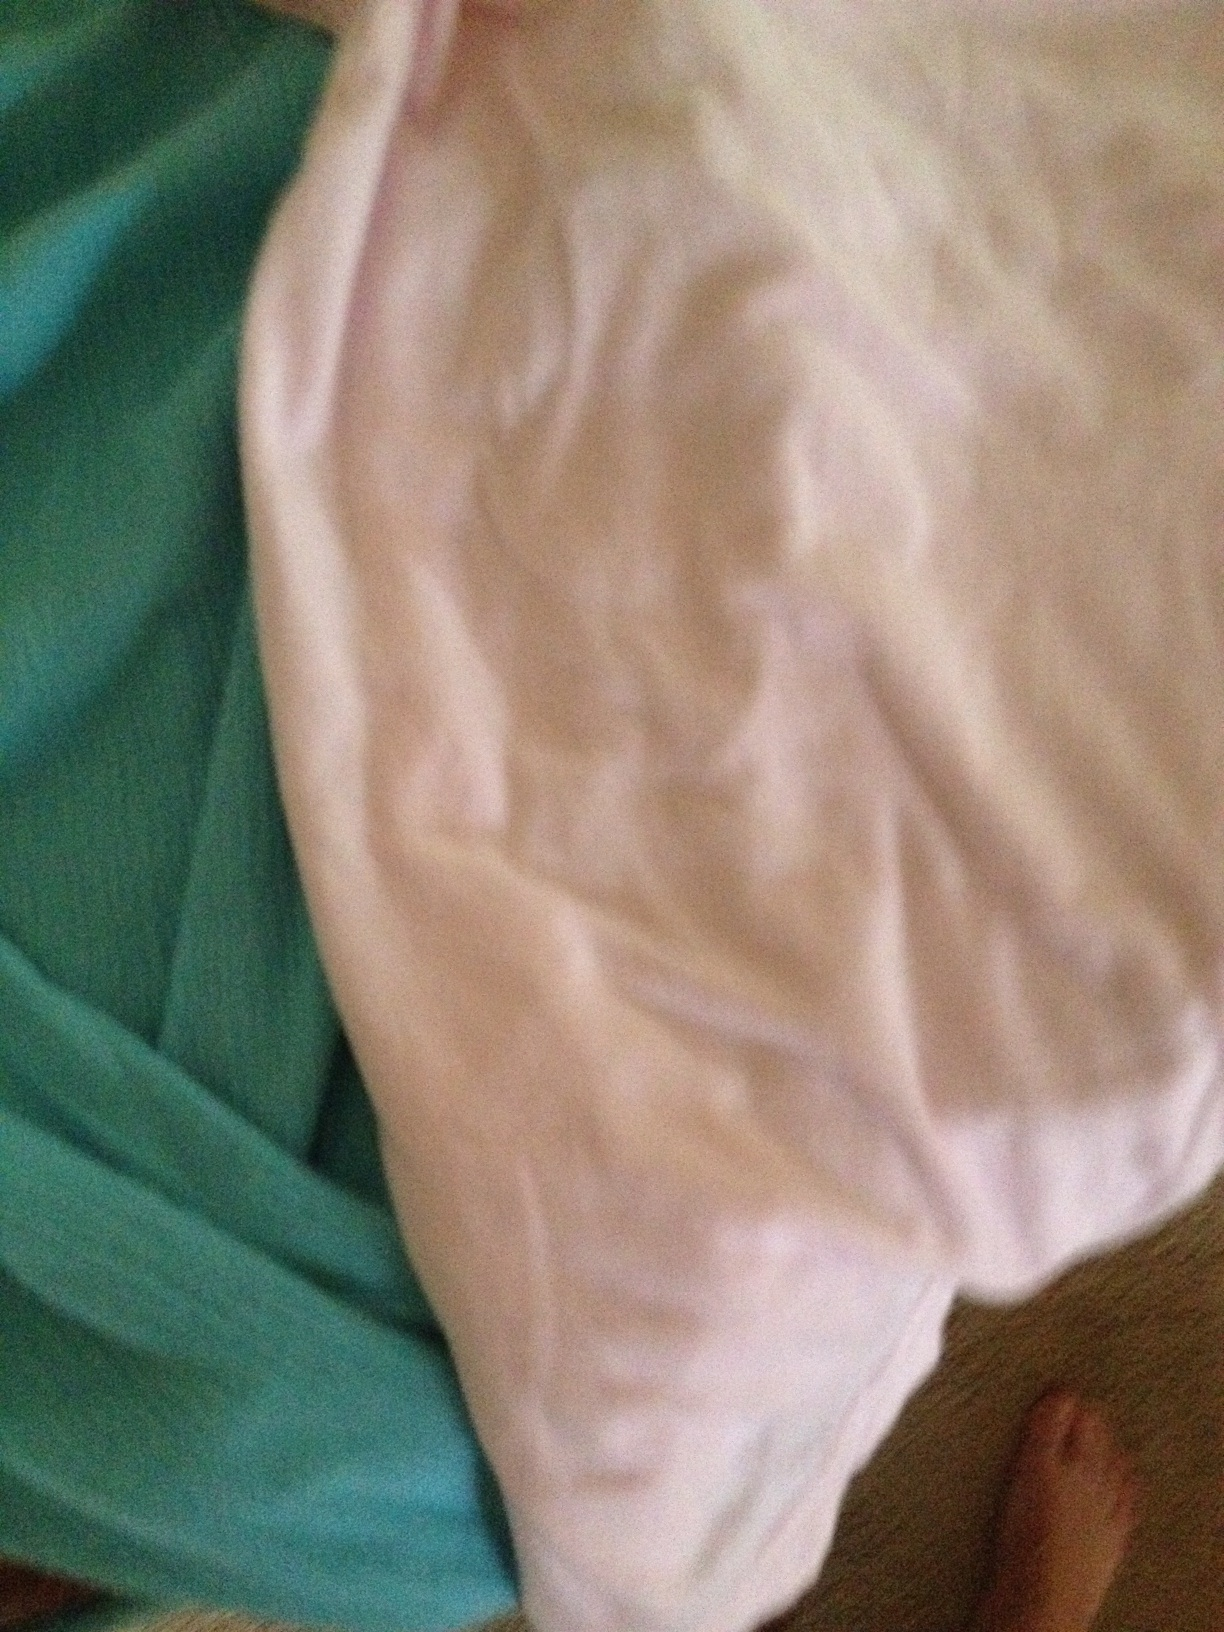Can you describe what you see in detail? In the image, I see two different fabric items lying on a surface. One fabric item is teal in color and has a textured pattern. The other fabric item is white and appears to be smooth with some wrinkles. In the bottom right corner of the image, a person's bare foot is partially visible, suggesting the items might be on a floor or a large piece of furniture. What kind of creative uses could these fabrics have? The teal and white fabrics could have several creative uses. They could be used for: 1) Making a DIY craft project such as patchwork quilts, cushion covers, or decorative pillows.

2) Designing a unique fashion piece, like a stylish dress, a set of rock concert-themed outfits, or even a fantasy costume.

3) Creating an artistic backdrop for photography or a themed party setup.

4) Transforming them into fabric-based artwork, like a collage or wall hanging.

5) Using them in clever interior design solutions, like custom curtains, table linens, or drapes.

The possibilities are only limited by the imagination! 